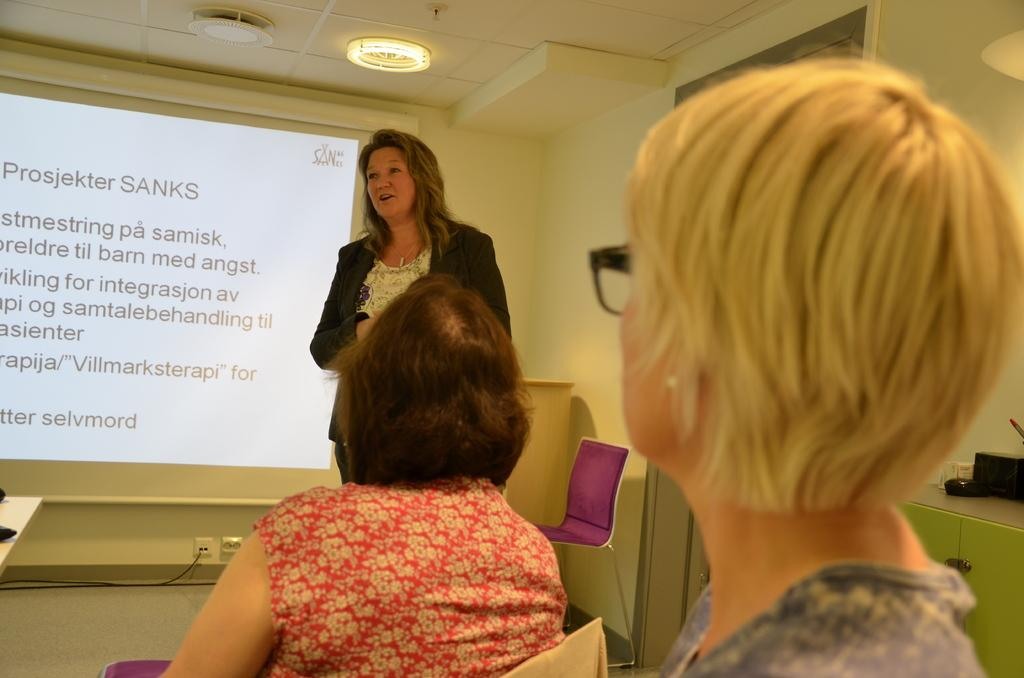What is the person in the image doing? The person is speaking in the image. How many people are present in the image? There are people in the image. What is displayed on the screen in the image? There is a screen with text in the image. What type of furniture is present in the image? There are chairs in the image. What items can be seen on the desk in the image? There are objects on a desk in the image. What type of lighting is present in the image? There are lights attached to the ceiling in the image. How does the person in the image jump over the stamp? There is no stamp present in the image, and the person is not jumping. 